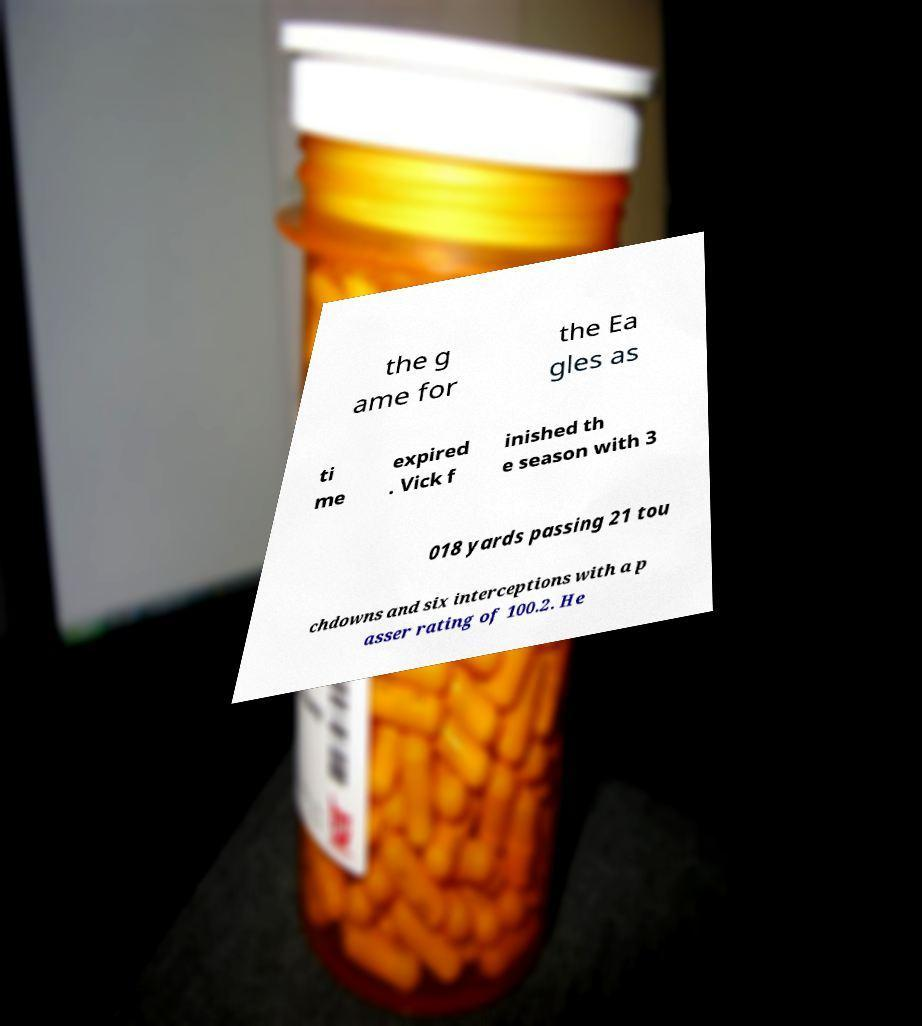Please read and relay the text visible in this image. What does it say? the g ame for the Ea gles as ti me expired . Vick f inished th e season with 3 018 yards passing 21 tou chdowns and six interceptions with a p asser rating of 100.2. He 